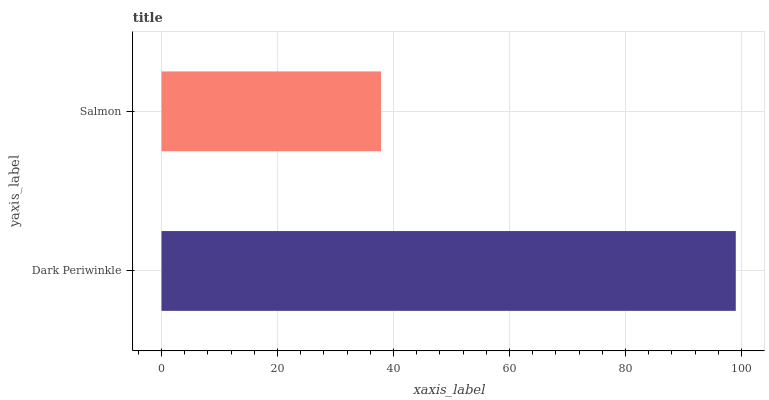Is Salmon the minimum?
Answer yes or no. Yes. Is Dark Periwinkle the maximum?
Answer yes or no. Yes. Is Salmon the maximum?
Answer yes or no. No. Is Dark Periwinkle greater than Salmon?
Answer yes or no. Yes. Is Salmon less than Dark Periwinkle?
Answer yes or no. Yes. Is Salmon greater than Dark Periwinkle?
Answer yes or no. No. Is Dark Periwinkle less than Salmon?
Answer yes or no. No. Is Dark Periwinkle the high median?
Answer yes or no. Yes. Is Salmon the low median?
Answer yes or no. Yes. Is Salmon the high median?
Answer yes or no. No. Is Dark Periwinkle the low median?
Answer yes or no. No. 